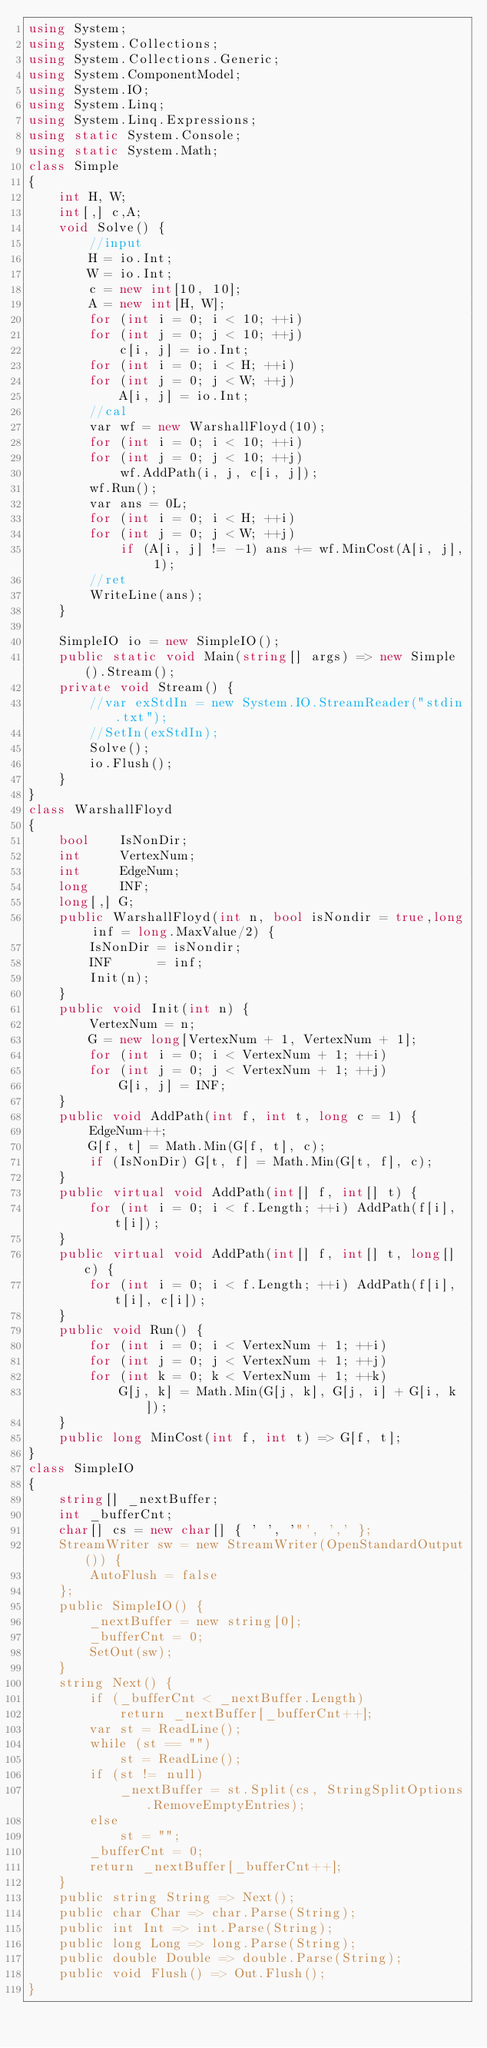Convert code to text. <code><loc_0><loc_0><loc_500><loc_500><_C#_>using System;
using System.Collections;
using System.Collections.Generic;
using System.ComponentModel;
using System.IO;
using System.Linq;
using System.Linq.Expressions;
using static System.Console;
using static System.Math;
class Simple
{
    int H, W;
    int[,] c,A;
    void Solve() {
        //input
        H = io.Int;
        W = io.Int;
        c = new int[10, 10];
        A = new int[H, W];
        for (int i = 0; i < 10; ++i)
        for (int j = 0; j < 10; ++j)
            c[i, j] = io.Int;
        for (int i = 0; i < H; ++i)
        for (int j = 0; j < W; ++j)
            A[i, j] = io.Int;
        //cal
        var wf = new WarshallFloyd(10);
        for (int i = 0; i < 10; ++i)
        for (int j = 0; j < 10; ++j)
            wf.AddPath(i, j, c[i, j]);
        wf.Run();
        var ans = 0L;
        for (int i = 0; i < H; ++i)
        for (int j = 0; j < W; ++j)
            if (A[i, j] != -1) ans += wf.MinCost(A[i, j], 1);
        //ret
        WriteLine(ans);
    }

    SimpleIO io = new SimpleIO();
    public static void Main(string[] args) => new Simple().Stream();
    private void Stream() {
        //var exStdIn = new System.IO.StreamReader("stdin.txt");
        //SetIn(exStdIn);
        Solve();
        io.Flush();
    }
}
class WarshallFloyd
{
    bool    IsNonDir;
    int     VertexNum;
    int     EdgeNum;
    long    INF;
    long[,] G;
    public WarshallFloyd(int n, bool isNondir = true,long inf = long.MaxValue/2) {
        IsNonDir = isNondir;
        INF      = inf;
        Init(n);
    }
    public void Init(int n) {
        VertexNum = n;
        G = new long[VertexNum + 1, VertexNum + 1];
        for (int i = 0; i < VertexNum + 1; ++i)
        for (int j = 0; j < VertexNum + 1; ++j)
            G[i, j] = INF;
    }
    public void AddPath(int f, int t, long c = 1) {
        EdgeNum++;
        G[f, t] = Math.Min(G[f, t], c);
        if (IsNonDir) G[t, f] = Math.Min(G[t, f], c);
    }
    public virtual void AddPath(int[] f, int[] t) {
        for (int i = 0; i < f.Length; ++i) AddPath(f[i], t[i]);
    }
    public virtual void AddPath(int[] f, int[] t, long[] c) {
        for (int i = 0; i < f.Length; ++i) AddPath(f[i], t[i], c[i]);
    }
    public void Run() {
        for (int i = 0; i < VertexNum + 1; ++i)
        for (int j = 0; j < VertexNum + 1; ++j)
        for (int k = 0; k < VertexNum + 1; ++k)
            G[j, k] = Math.Min(G[j, k], G[j, i] + G[i, k]);
    }
    public long MinCost(int f, int t) => G[f, t];
}
class SimpleIO
{
    string[] _nextBuffer;
    int _bufferCnt;
    char[] cs = new char[] { ' ', '"', ',' };
    StreamWriter sw = new StreamWriter(OpenStandardOutput()) {
        AutoFlush = false
    };
    public SimpleIO() {
        _nextBuffer = new string[0];
        _bufferCnt = 0;
        SetOut(sw);
    }
    string Next() {
        if (_bufferCnt < _nextBuffer.Length)
            return _nextBuffer[_bufferCnt++];
        var st = ReadLine();
        while (st == "")
            st = ReadLine();
        if (st != null)
            _nextBuffer = st.Split(cs, StringSplitOptions.RemoveEmptyEntries);
        else
            st = "";
        _bufferCnt = 0;
        return _nextBuffer[_bufferCnt++];
    }
    public string String => Next();
    public char Char => char.Parse(String);
    public int Int => int.Parse(String);
    public long Long => long.Parse(String);
    public double Double => double.Parse(String);
    public void Flush() => Out.Flush();
}
</code> 